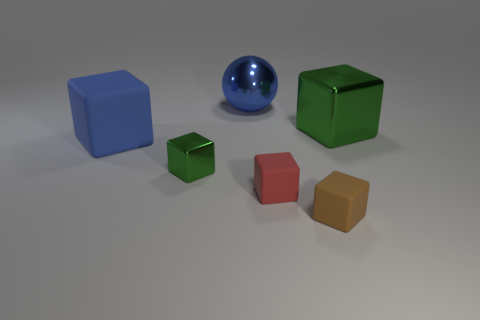Can you describe the color and shape of the object directly in the center of this image? The object directly in the center of the image is a sphere with a glossy, reflective surface. Its color is a deep, rich blue, and it stands out against the neutral background due to its vibrant hue and distinct spherical shape. 